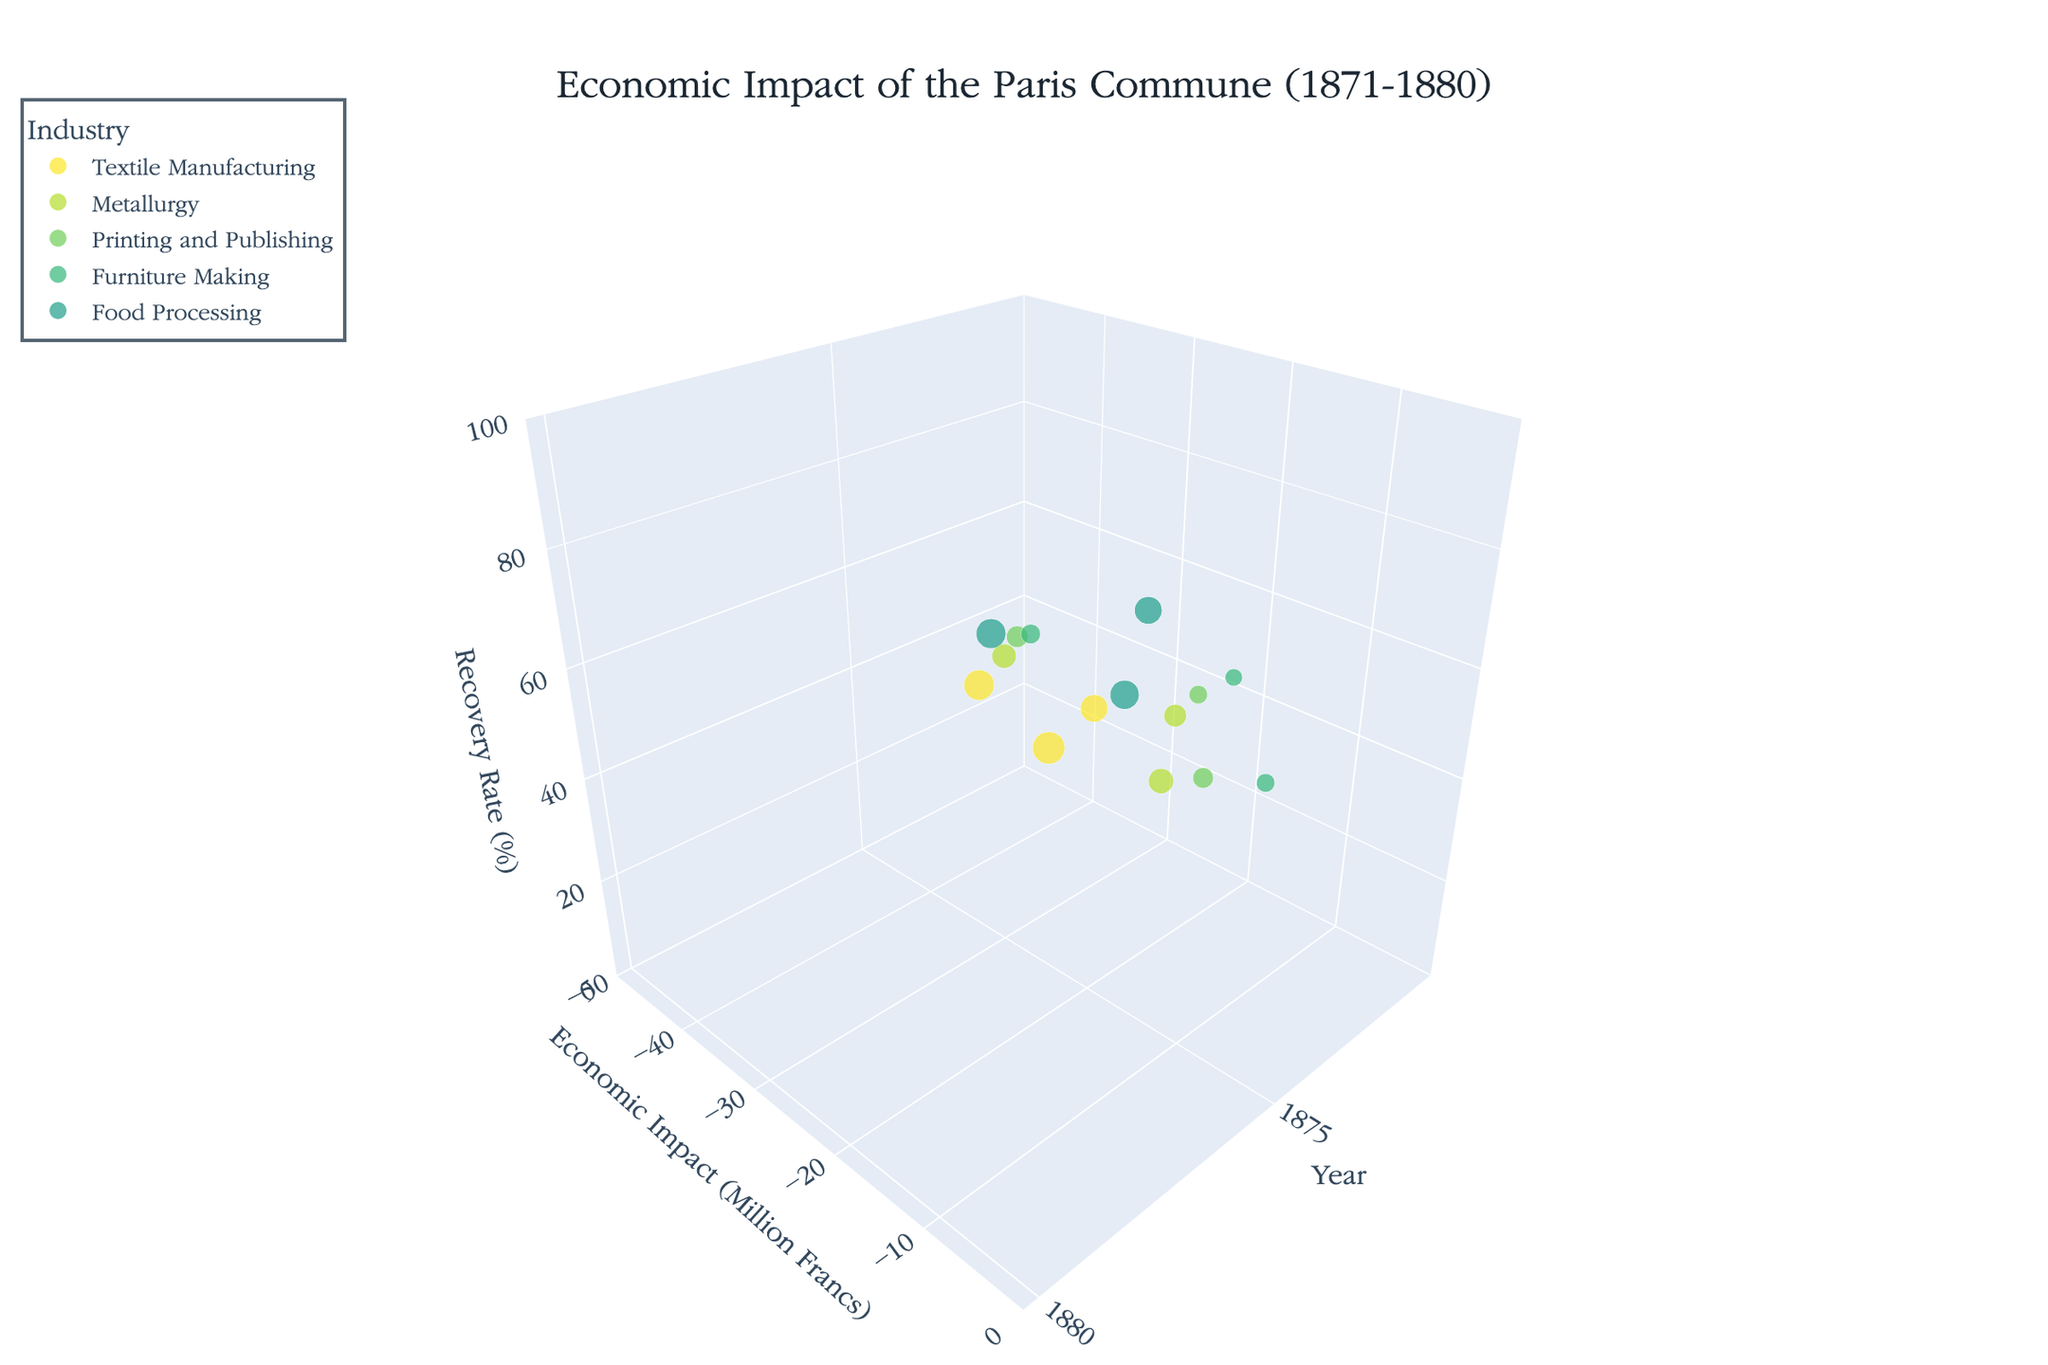What is the title of the chart? The title is displayed at the top of the chart, which provides an overview of the depicted information. In this case, the title is located at the center-top and reads, "Economic Impact of the Paris Commune (1871-1880)."
Answer: Economic Impact of the Paris Commune (1871-1880) What do the axes represent in the chart? The chart features three axes. The x-axis represents the "Year," the y-axis shows the "Economic Impact (Million Francs)," and the z-axis indicates the "Recovery Rate (%)". These axes help to contextualize the plotted data points in terms of time, economic impact, and recovery rate.
Answer: Year, Economic Impact (Million Francs), Recovery Rate (%) Which industry has the largest bubble in 1871? In a 3D bubble chart, the size of the bubbles represents the "Workforce Affected (Thousands)". By inspecting the bubble sizes for the year 1871, the Food Processing industry has the largest bubble, indicating the highest workforce affected of 20,000.
Answer: Food Processing How does the economic impact of Textile Manufacturing change between 1871 and 1880? The Textile Manufacturing industry has data points at 1871 (-45 million Francs), 1875 (-20 million Francs), and 1880 (-5 million Francs). The economic impact improves over time, reducing the negative impact from -45 million Francs in 1871 to -5 million Francs in 1880.
Answer: Improves from -45 million Francs to -5 million Francs Which industry had the highest recovery rate in 1880? By analyzing the z-axis values (Recovery Rate %) for the year 1880, we see that several industries have high recovery rates, but Furniture Making has the highest at 99%.
Answer: Furniture Making Between which two years did Print and Publishing see the most significant improvement in economic impact? For the Print and Publishing industry, the economic impacts are -25 million Francs in 1871, -10 million Francs in 1875, and -2 million Francs in 1880. The most significant improvement occurs between 1871 and 1875, where the economic impact improves by 15 million Francs (from -25 million to -10 million).
Answer: Between 1871 and 1875 In which year did the Food Processing industry have a recovery rate of 75%? Observing the z-axis values corresponding to the Food Processing industry, a recovery rate of 75% is achieved in the year 1875.
Answer: 1875 Compare the workforce affected in Metallurgy in 1871 and 1880. What can be inferred about the trend? The number of workforce affected in Metallurgy is 15,000 in 1871 and 14,000 in 1880. There is a slight decrease in the workforce affected by 1,000 over this period, indicating improved stability in employment levels within the industry.
Answer: Decreases from 15,000 to 14,000 What is the average recovery rate of the Textile Manufacturing industry over the three time points? The recovery rates for Textile Manufacturing are 10% in 1871, 55% in 1875, and 90% in 1880. The average recovery rate is calculated by summing these values and then dividing by the number of data points: (10 + 55 + 90) / 3 = 51.67%.
Answer: 51.67% 